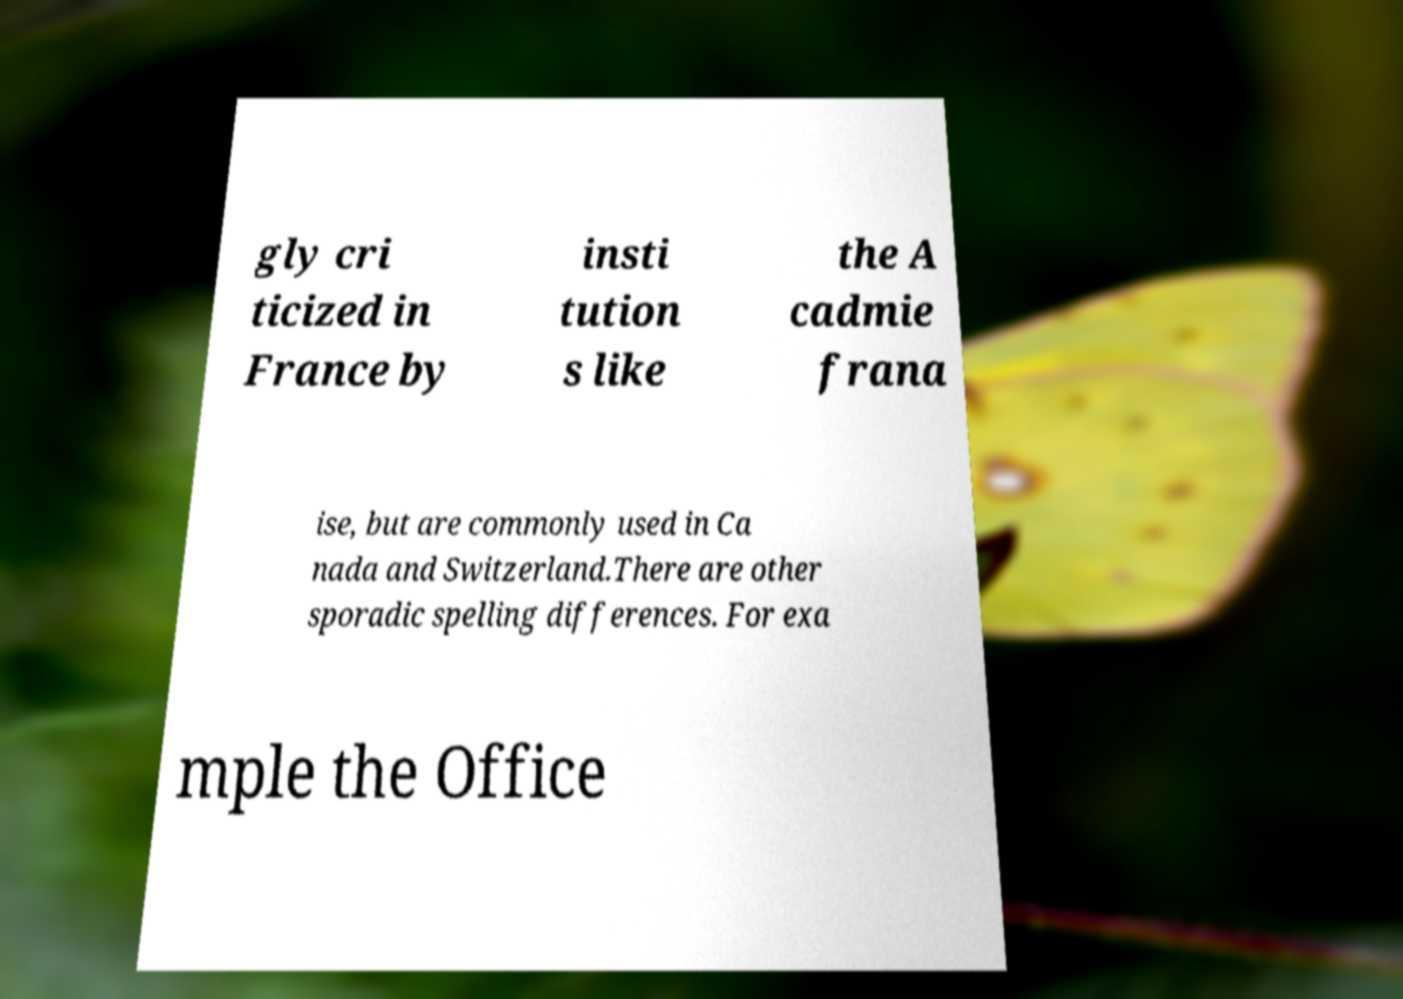Can you read and provide the text displayed in the image?This photo seems to have some interesting text. Can you extract and type it out for me? gly cri ticized in France by insti tution s like the A cadmie frana ise, but are commonly used in Ca nada and Switzerland.There are other sporadic spelling differences. For exa mple the Office 